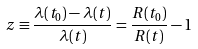<formula> <loc_0><loc_0><loc_500><loc_500>z \equiv \frac { \lambda ( t _ { 0 } ) - \lambda ( t ) } { \lambda ( t ) } = \frac { R ( t _ { 0 } ) } { R ( t ) } - 1</formula> 